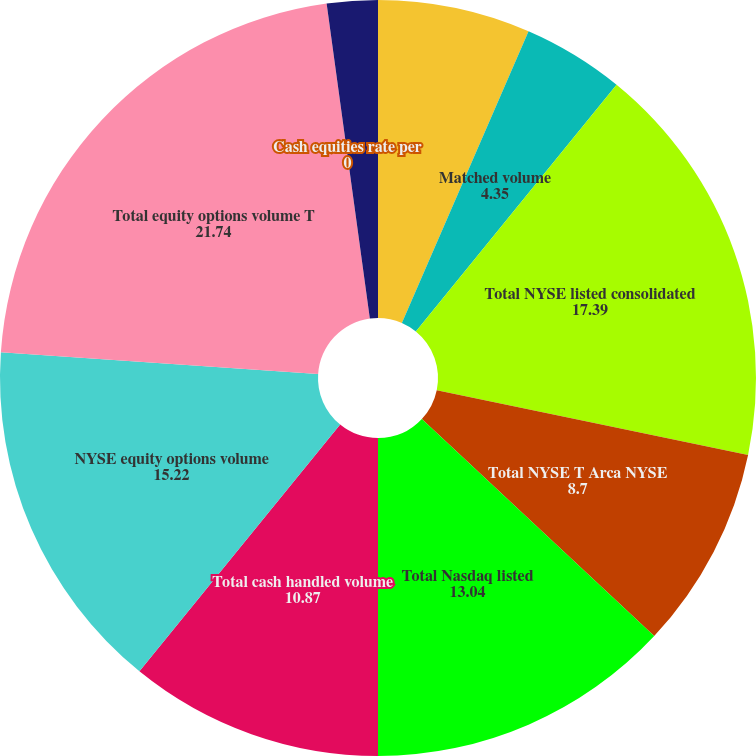<chart> <loc_0><loc_0><loc_500><loc_500><pie_chart><fcel>Handled volume<fcel>Matched volume<fcel>Total NYSE listed consolidated<fcel>Total NYSE T Arca NYSE<fcel>Total Nasdaq listed<fcel>Total cash handled volume<fcel>NYSE equity options volume<fcel>Total equity options volume T<fcel>Cash equities rate per<fcel>Equity options rate per<nl><fcel>6.52%<fcel>4.35%<fcel>17.39%<fcel>8.7%<fcel>13.04%<fcel>10.87%<fcel>15.22%<fcel>21.74%<fcel>0.0%<fcel>2.17%<nl></chart> 